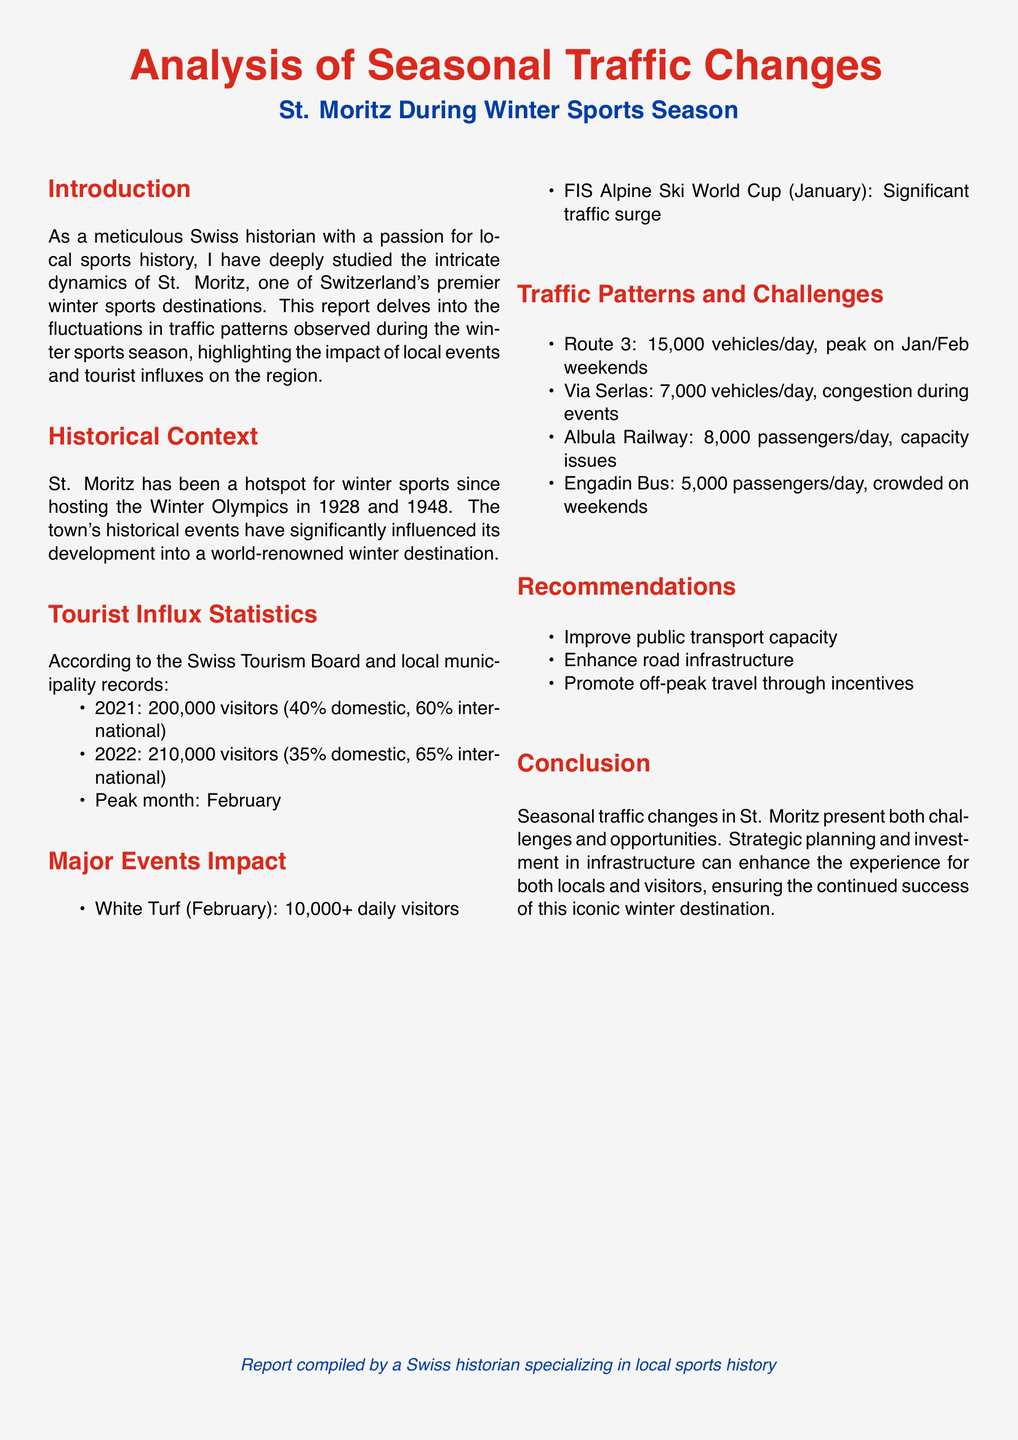what was the peak month for visitors in St. Moritz? The document states that February is the peak month for visitors.
Answer: February how many visitors did St. Moritz receive in 2022? According to the statistics, St. Moritz received 210,000 visitors in 2022.
Answer: 210,000 what percentage of visitors in 2021 were international? The document mentions that 60% of visitors in 2021 were international.
Answer: 60% which major event caused a significant traffic surge in January? The report indicates that the FIS Alpine Ski World Cup caused a significant traffic surge in January.
Answer: FIS Alpine Ski World Cup how many vehicles per day does Route 3 experience? The report states that Route 3 has 15,000 vehicles per day.
Answer: 15,000 what are the recommendations made in the report? The recommendations include improving public transport capacity, enhancing road infrastructure, and promoting off-peak travel through incentives.
Answer: Improve public transport capacity, enhance road infrastructure, promote off-peak travel what is the daily passenger capacity issue mentioned for Albula Railway? The report provides that Albula Railway has 8,000 passengers per day experiencing capacity issues.
Answer: 8,000 how many daily visitors does the White Turf event attract? The document notes that the White Turf event attracts over 10,000 daily visitors.
Answer: 10,000+ what type of report is this document? The document is an analysis of seasonal traffic changes in St. Moritz during the winter sports season.
Answer: Traffic report 